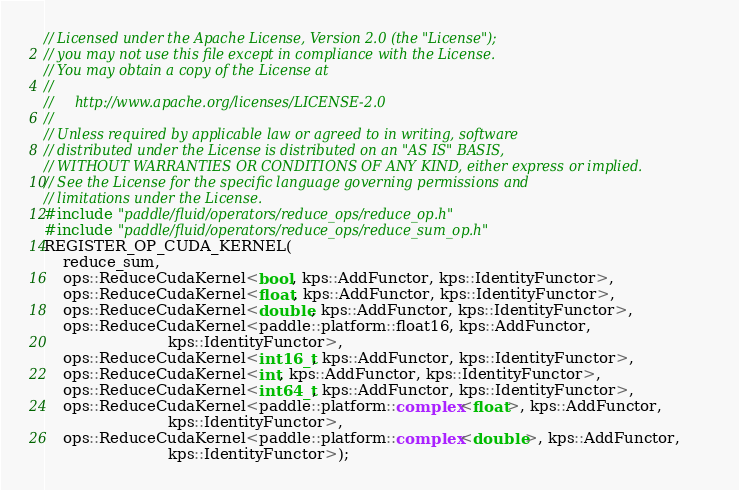Convert code to text. <code><loc_0><loc_0><loc_500><loc_500><_Cuda_>// Licensed under the Apache License, Version 2.0 (the "License");
// you may not use this file except in compliance with the License.
// You may obtain a copy of the License at
//
//     http://www.apache.org/licenses/LICENSE-2.0
//
// Unless required by applicable law or agreed to in writing, software
// distributed under the License is distributed on an "AS IS" BASIS,
// WITHOUT WARRANTIES OR CONDITIONS OF ANY KIND, either express or implied.
// See the License for the specific language governing permissions and
// limitations under the License.
#include "paddle/fluid/operators/reduce_ops/reduce_op.h"
#include "paddle/fluid/operators/reduce_ops/reduce_sum_op.h"
REGISTER_OP_CUDA_KERNEL(
    reduce_sum,
    ops::ReduceCudaKernel<bool, kps::AddFunctor, kps::IdentityFunctor>,
    ops::ReduceCudaKernel<float, kps::AddFunctor, kps::IdentityFunctor>,
    ops::ReduceCudaKernel<double, kps::AddFunctor, kps::IdentityFunctor>,
    ops::ReduceCudaKernel<paddle::platform::float16, kps::AddFunctor,
                          kps::IdentityFunctor>,
    ops::ReduceCudaKernel<int16_t, kps::AddFunctor, kps::IdentityFunctor>,
    ops::ReduceCudaKernel<int, kps::AddFunctor, kps::IdentityFunctor>,
    ops::ReduceCudaKernel<int64_t, kps::AddFunctor, kps::IdentityFunctor>,
    ops::ReduceCudaKernel<paddle::platform::complex<float>, kps::AddFunctor,
                          kps::IdentityFunctor>,
    ops::ReduceCudaKernel<paddle::platform::complex<double>, kps::AddFunctor,
                          kps::IdentityFunctor>);
</code> 